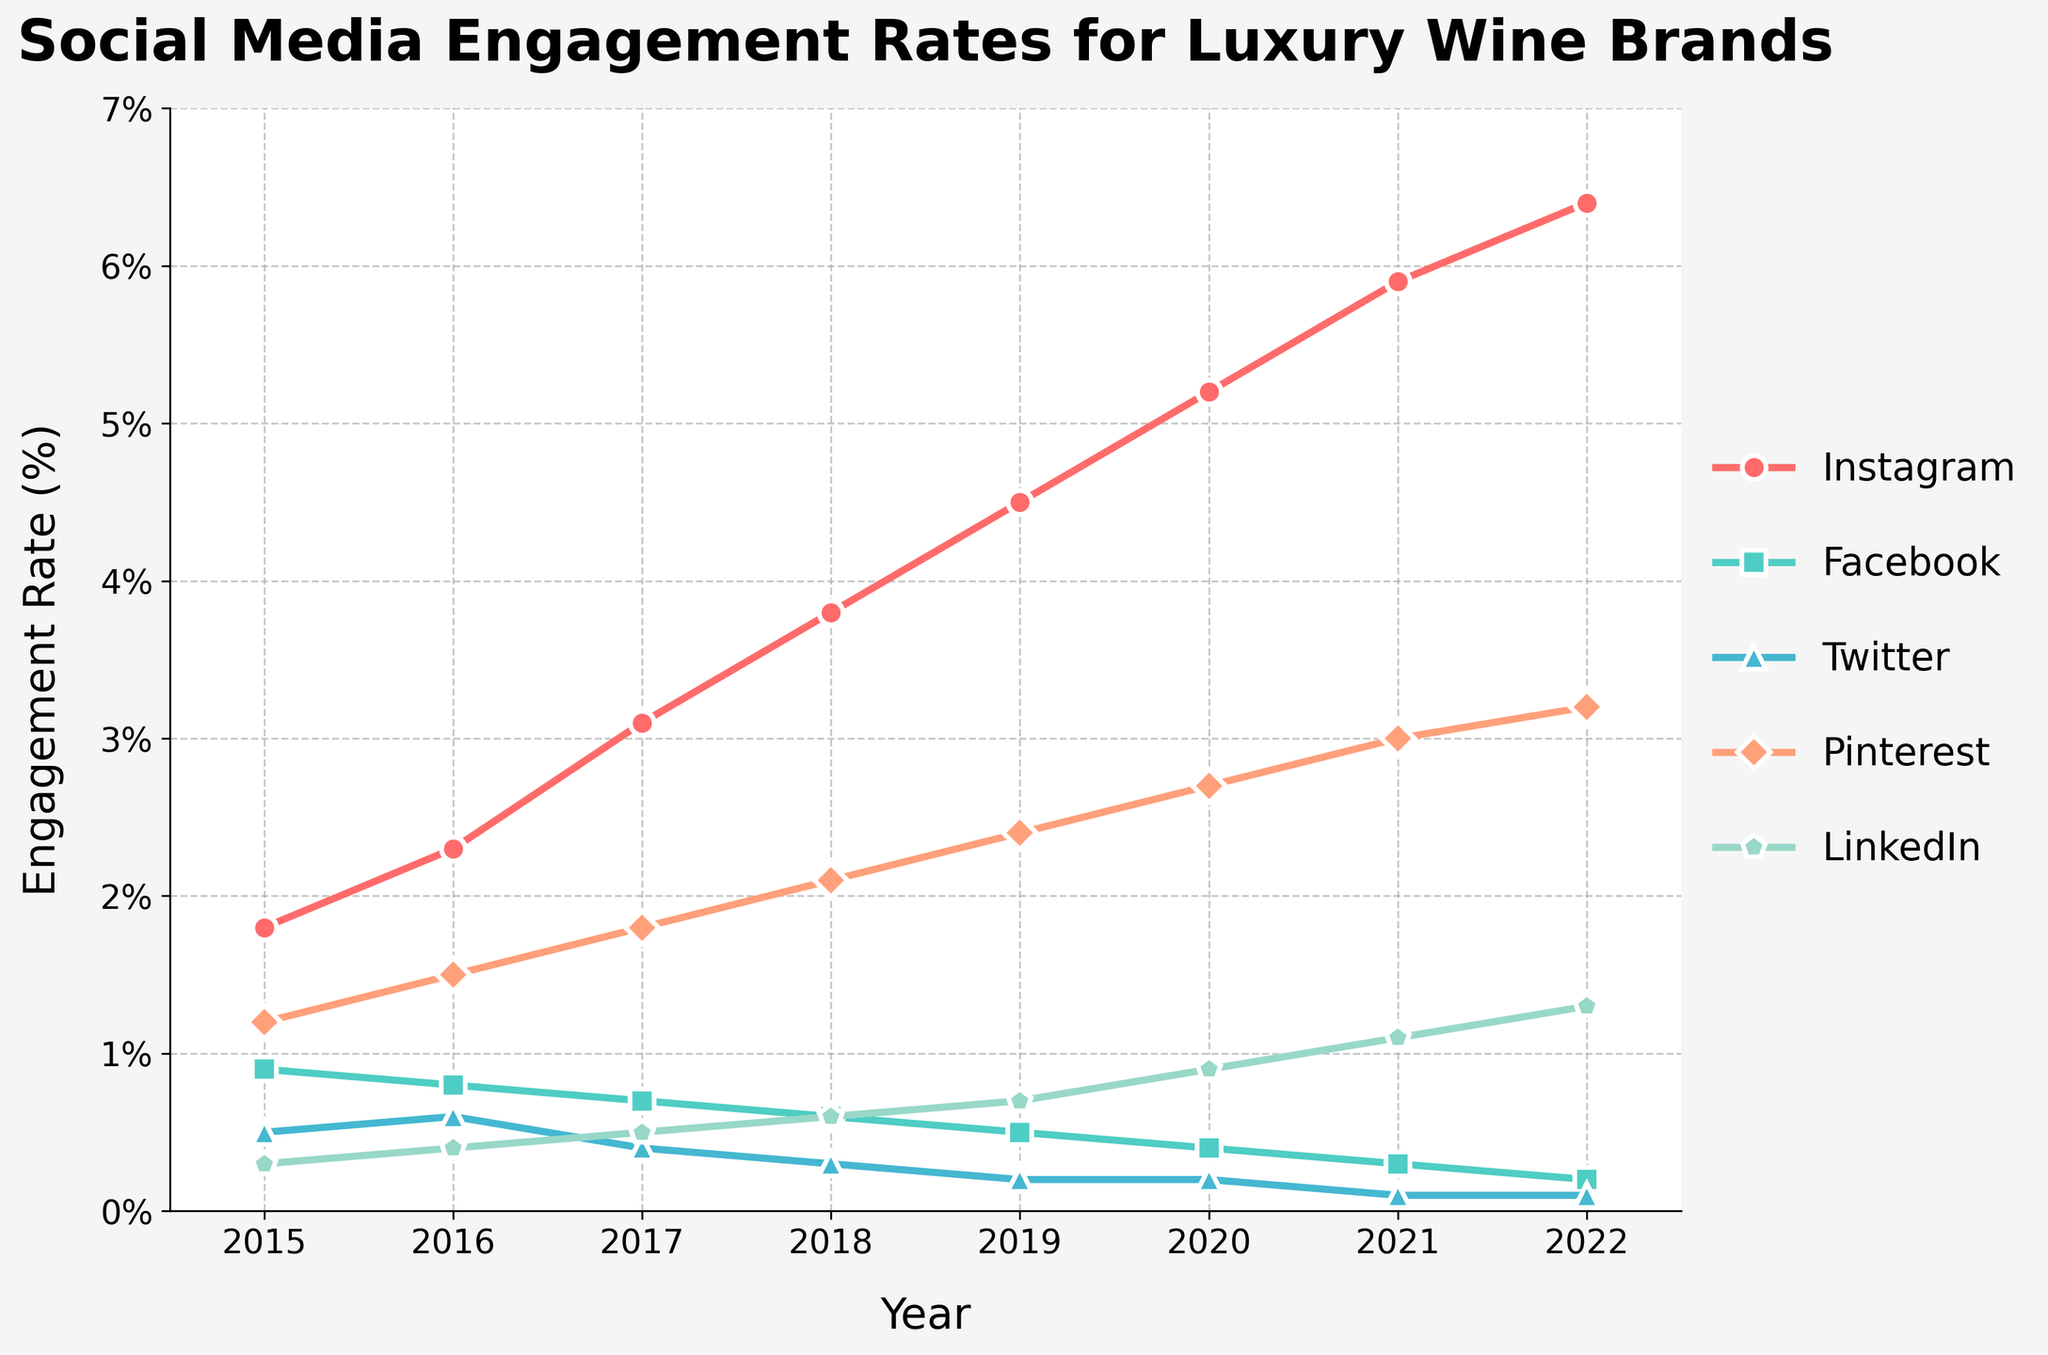What's the trend in Instagram engagement rates from 2015 to 2022? The Instagram engagement rate has consistently increased each year. Starting from 1.8% in 2015, it reaches 6.4% by 2022.
Answer: Increasing How does the engagement rate of LinkedIn in 2015 compare to its rate in 2022? In 2015, LinkedIn had an engagement rate of 0.3%. By 2022, this increased to 1.3%. Comparing the two, LinkedIn's engagement rate in 2022 is higher than in 2015.
Answer: Higher Which platform had the smallest increase in engagement rate from 2015 to 2022? Twitter had the smallest increase in engagement rate, starting at 0.5% in 2015 and ending at 0.1% in 2022, which is actually a decrease.
Answer: Twitter Which year did Pinterest surpass a 2% engagement rate? Pinterest's engagement rate surpassed 2% in 2018, where its rate was 2.1%.
Answer: 2018 Compare the engagement rates of Facebook and Pinterest in 2019. In 2019, Facebook had an engagement rate of 0.5% while Pinterest had an engagement rate of 2.4%. Therefore, Pinterest had a higher engagement rate compared to Facebook in 2019.
Answer: Pinterest What is the average engagement rate of Instagram over the years shown in the chart? The engagement rates for Instagram from 2015 to 2022 are 1.8%, 2.3%, 3.1%, 3.8%, 4.5%, 5.2%, 5.9%, and 6.4%. Adding these rates together gives 33%. Dividing by 8 (the number of years) gives an average engagement rate of 4.125%.
Answer: 4.125% Between 2016 and 2020, which platform had the largest drop in engagement rate? Facebook had a drop from 0.8% in 2016 to 0.4% in 2020.
Answer: Facebook What visual trend is noticeable for Twitter's engagement rate over the years? The noticeable trend is a continuous decrease in Twitter's engagement rate, dropping sharply each year from 2015, and eventually plateauing at 0.1% since 2021.
Answer: Decreasing Which platform's engagement rate in 2020 was twice its rate in 2015? Instagram had an engagement rate of 5.2% in 2020, which is almost three times its rate of 1.8% in 2015. LinkedIn had an engagement rate of 0.9% in 2020, which is three times its rate of 0.3% in 2015.
Answer: LinkedIn 